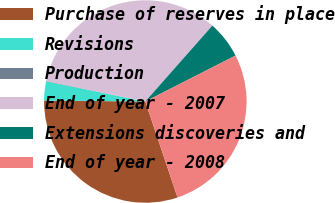Convert chart to OTSL. <chart><loc_0><loc_0><loc_500><loc_500><pie_chart><fcel>Purchase of reserves in place<fcel>Revisions<fcel>Production<fcel>End of year - 2007<fcel>Extensions discoveries and<fcel>End of year - 2008<nl><fcel>30.3%<fcel>3.03%<fcel>0.07%<fcel>33.26%<fcel>5.99%<fcel>27.34%<nl></chart> 